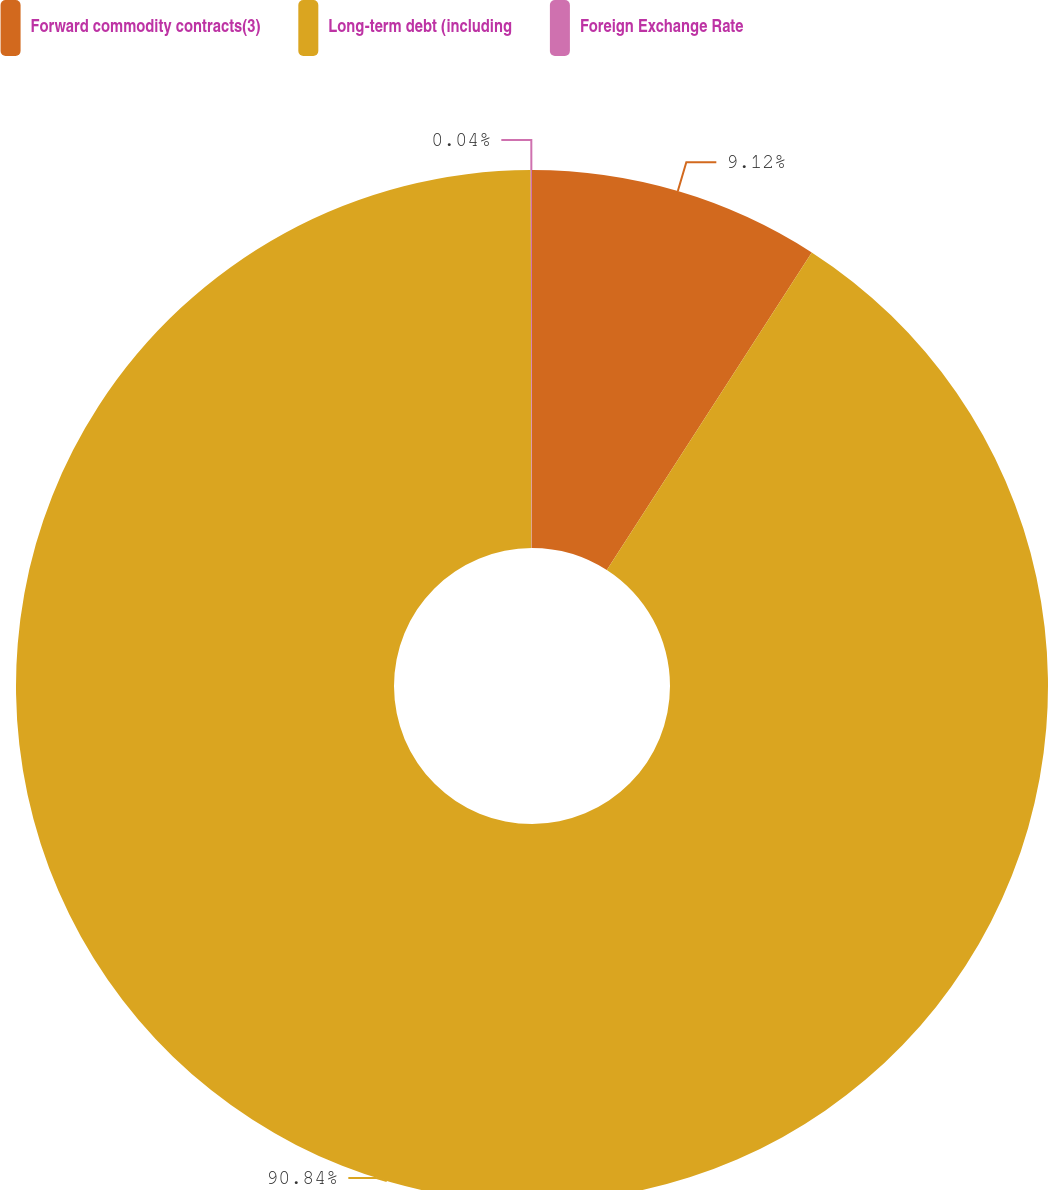Convert chart. <chart><loc_0><loc_0><loc_500><loc_500><pie_chart><fcel>Forward commodity contracts(3)<fcel>Long-term debt (including<fcel>Foreign Exchange Rate<nl><fcel>9.12%<fcel>90.83%<fcel>0.04%<nl></chart> 